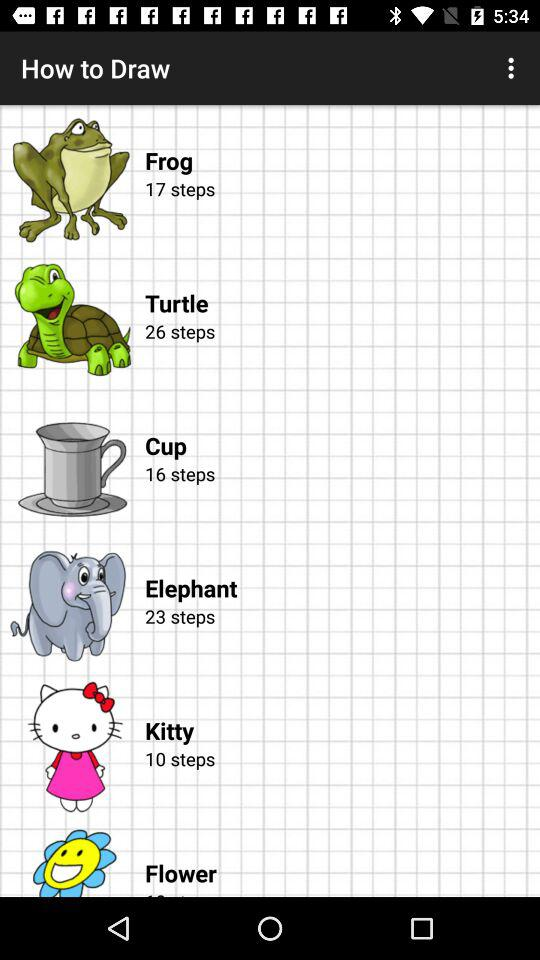For what item are 16 steps given? 16 steps are given for the cup. 